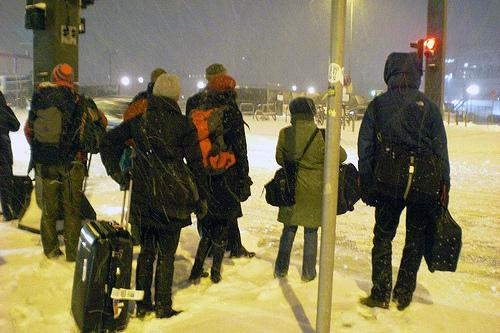Question: who is wearing hats?
Choices:
A. The scary clowns.
B. The group of people.
C. The babies.
D. The referees.
Answer with the letter. Answer: B Question: when was the photo taken?
Choices:
A. Night.
B. During a volcanic eruption.
C. Sunrise.
D. High noon.
Answer with the letter. Answer: A Question: what is falling onto the ground?
Choices:
A. Rain.
B. Snow.
C. Bird poop.
D. Volcanic ash.
Answer with the letter. Answer: B Question: what is on the ground?
Choices:
A. Snow.
B. Litter.
C. Leaves.
D. Grass.
Answer with the letter. Answer: A Question: how many people are in the photo?
Choices:
A. Four.
B. Five.
C. Eight.
D. Six.
Answer with the letter. Answer: C Question: who is wearing a navy blue jacket?
Choices:
A. Person on the right.
B. A scary clown.
C. The referee.
D. A baby.
Answer with the letter. Answer: A 